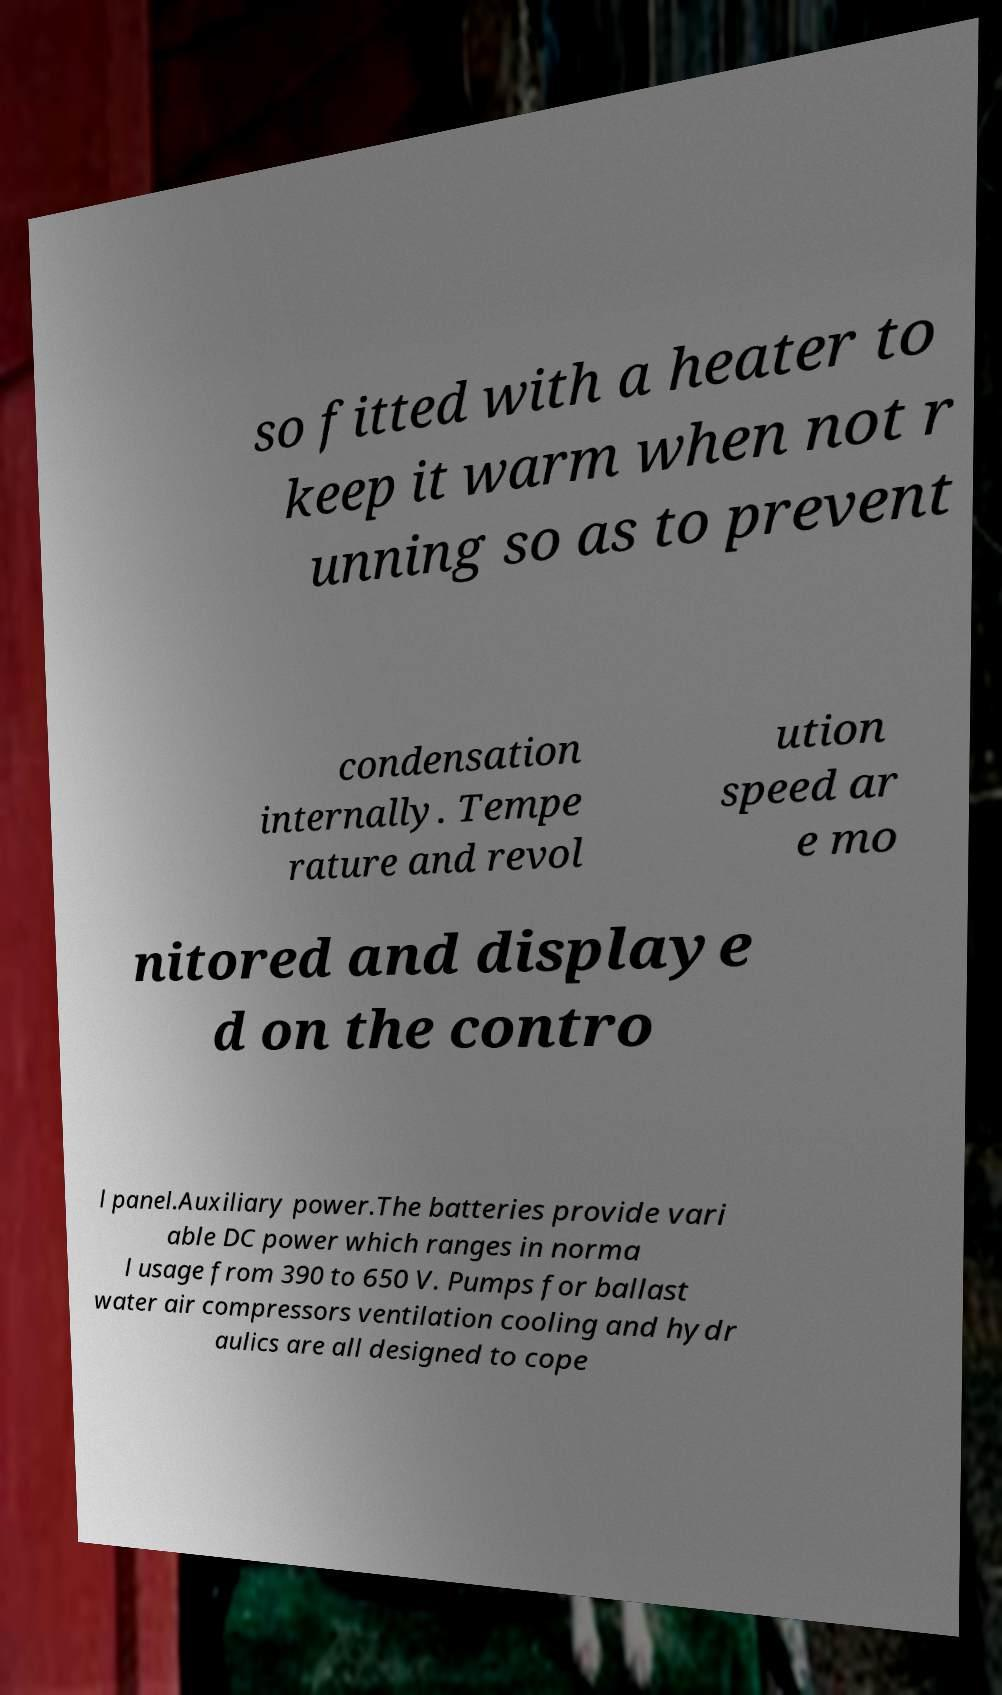Could you extract and type out the text from this image? so fitted with a heater to keep it warm when not r unning so as to prevent condensation internally. Tempe rature and revol ution speed ar e mo nitored and displaye d on the contro l panel.Auxiliary power.The batteries provide vari able DC power which ranges in norma l usage from 390 to 650 V. Pumps for ballast water air compressors ventilation cooling and hydr aulics are all designed to cope 